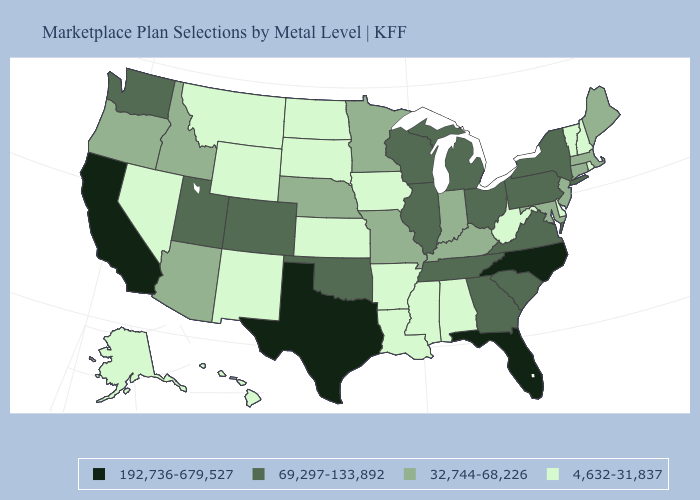What is the value of West Virginia?
Quick response, please. 4,632-31,837. Does New Mexico have the lowest value in the USA?
Keep it brief. Yes. Among the states that border Georgia , which have the highest value?
Be succinct. Florida, North Carolina. Does the first symbol in the legend represent the smallest category?
Give a very brief answer. No. Which states have the lowest value in the USA?
Keep it brief. Alabama, Alaska, Arkansas, Delaware, Hawaii, Iowa, Kansas, Louisiana, Mississippi, Montana, Nevada, New Hampshire, New Mexico, North Dakota, Rhode Island, South Dakota, Vermont, West Virginia, Wyoming. Name the states that have a value in the range 4,632-31,837?
Keep it brief. Alabama, Alaska, Arkansas, Delaware, Hawaii, Iowa, Kansas, Louisiana, Mississippi, Montana, Nevada, New Hampshire, New Mexico, North Dakota, Rhode Island, South Dakota, Vermont, West Virginia, Wyoming. Which states hav the highest value in the West?
Short answer required. California. Does Texas have the highest value in the USA?
Concise answer only. Yes. Does the first symbol in the legend represent the smallest category?
Answer briefly. No. Does Illinois have the highest value in the MidWest?
Write a very short answer. Yes. Among the states that border South Carolina , does North Carolina have the lowest value?
Be succinct. No. Does Oregon have a higher value than North Dakota?
Keep it brief. Yes. Name the states that have a value in the range 69,297-133,892?
Short answer required. Colorado, Georgia, Illinois, Michigan, New York, Ohio, Oklahoma, Pennsylvania, South Carolina, Tennessee, Utah, Virginia, Washington, Wisconsin. What is the value of New Jersey?
Be succinct. 32,744-68,226. 